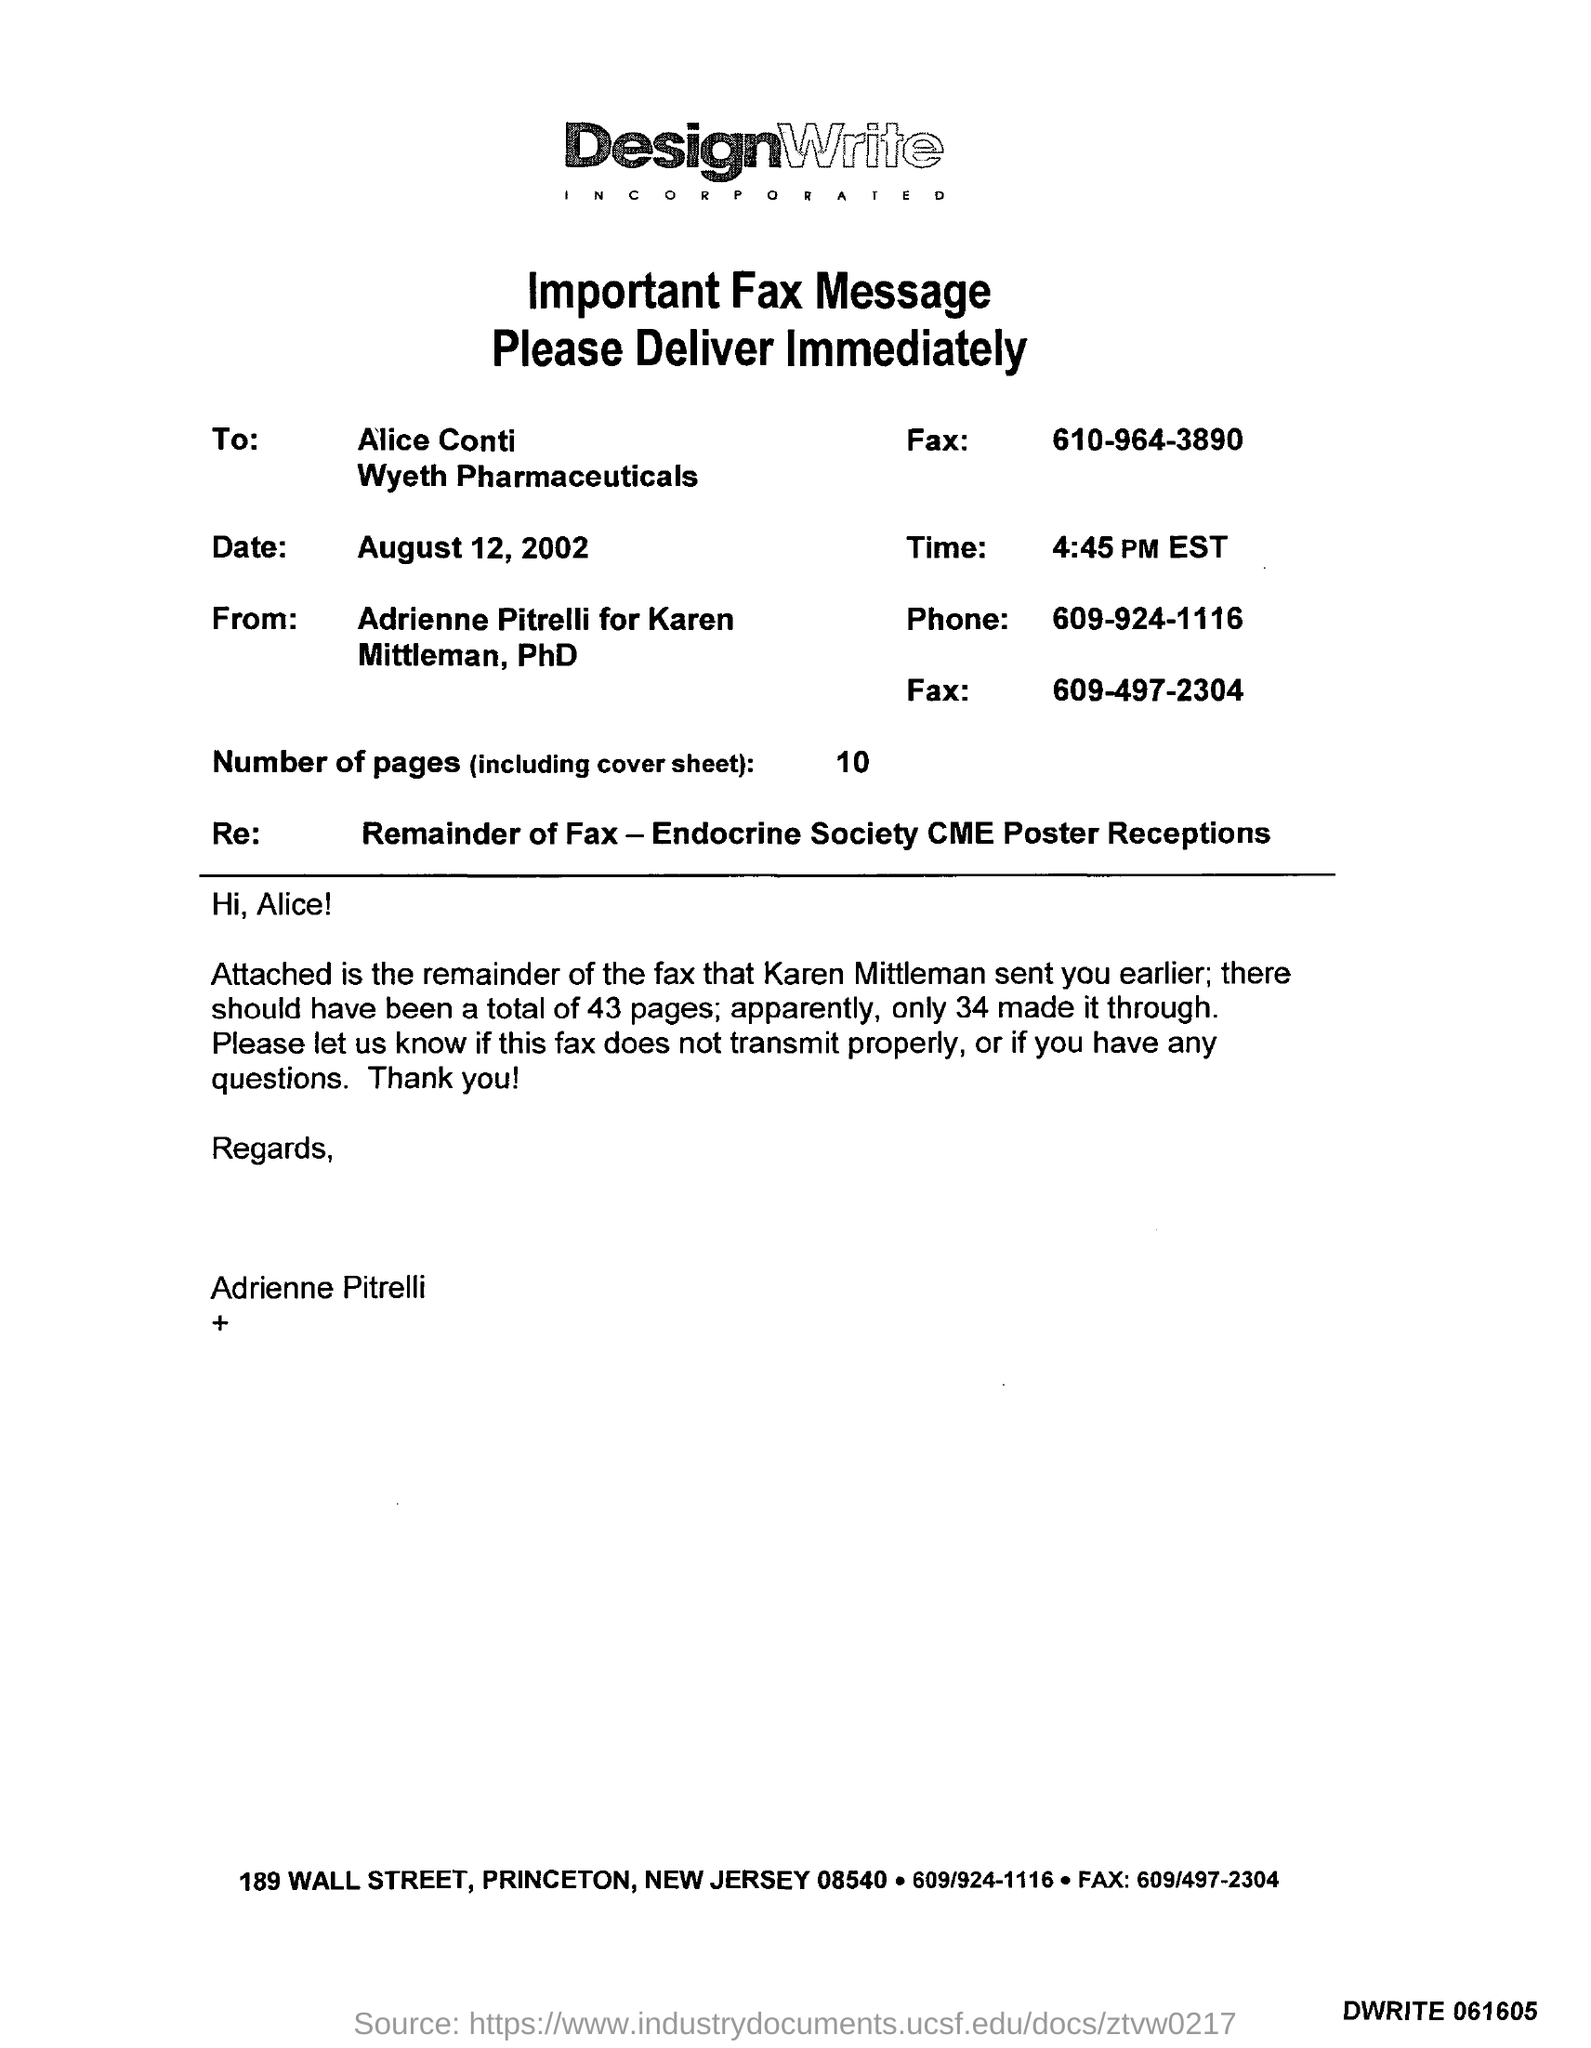Highlight a few significant elements in this photo. The phone number is 609-924-1116. The number of pages is 10. The date is August 12, 2002. It is currently 4:45 PM EST. 